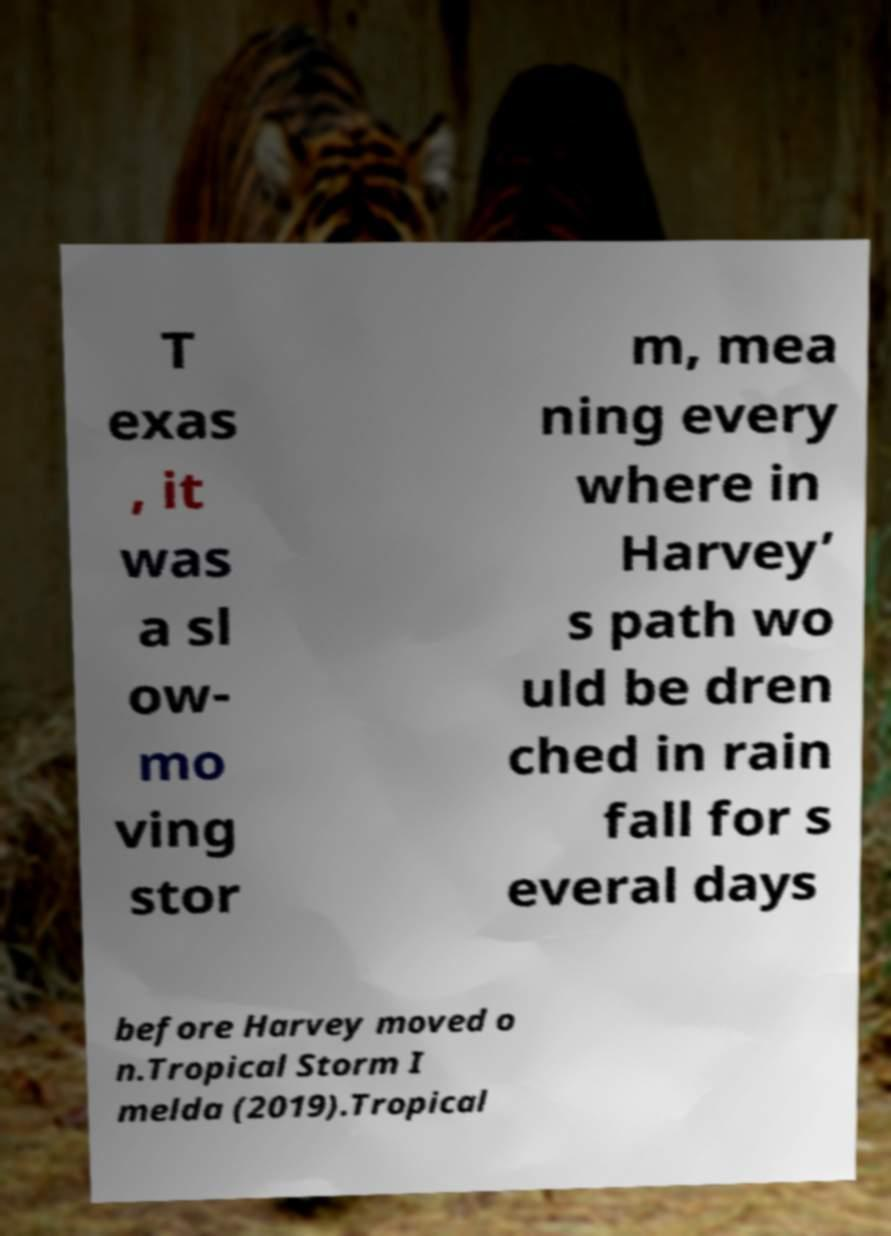Please identify and transcribe the text found in this image. T exas , it was a sl ow- mo ving stor m, mea ning every where in Harvey’ s path wo uld be dren ched in rain fall for s everal days before Harvey moved o n.Tropical Storm I melda (2019).Tropical 